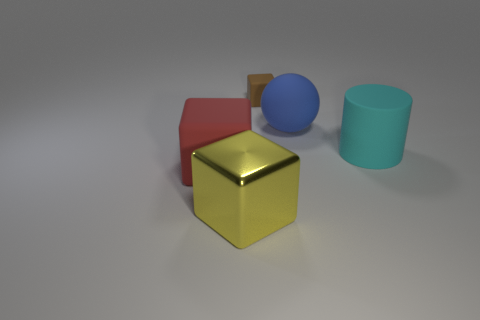There is another rubber object that is the same shape as the small matte object; what is its size?
Your response must be concise. Large. The metal cube is what size?
Your response must be concise. Large. Are there more cyan objects that are on the left side of the tiny brown thing than cyan matte objects?
Your answer should be compact. No. Are there any other things that have the same material as the brown object?
Give a very brief answer. Yes. There is a rubber cube that is behind the large red thing; is it the same color as the cube that is to the left of the yellow shiny block?
Your answer should be very brief. No. There is a block right of the large block in front of the rubber object that is on the left side of the big yellow block; what is it made of?
Ensure brevity in your answer.  Rubber. Is the number of blue matte things greater than the number of red cylinders?
Make the answer very short. Yes. Are there any other things that have the same color as the big metallic object?
Provide a short and direct response. No. What is the size of the blue sphere that is made of the same material as the large red object?
Provide a short and direct response. Large. What is the material of the brown block?
Give a very brief answer. Rubber. 